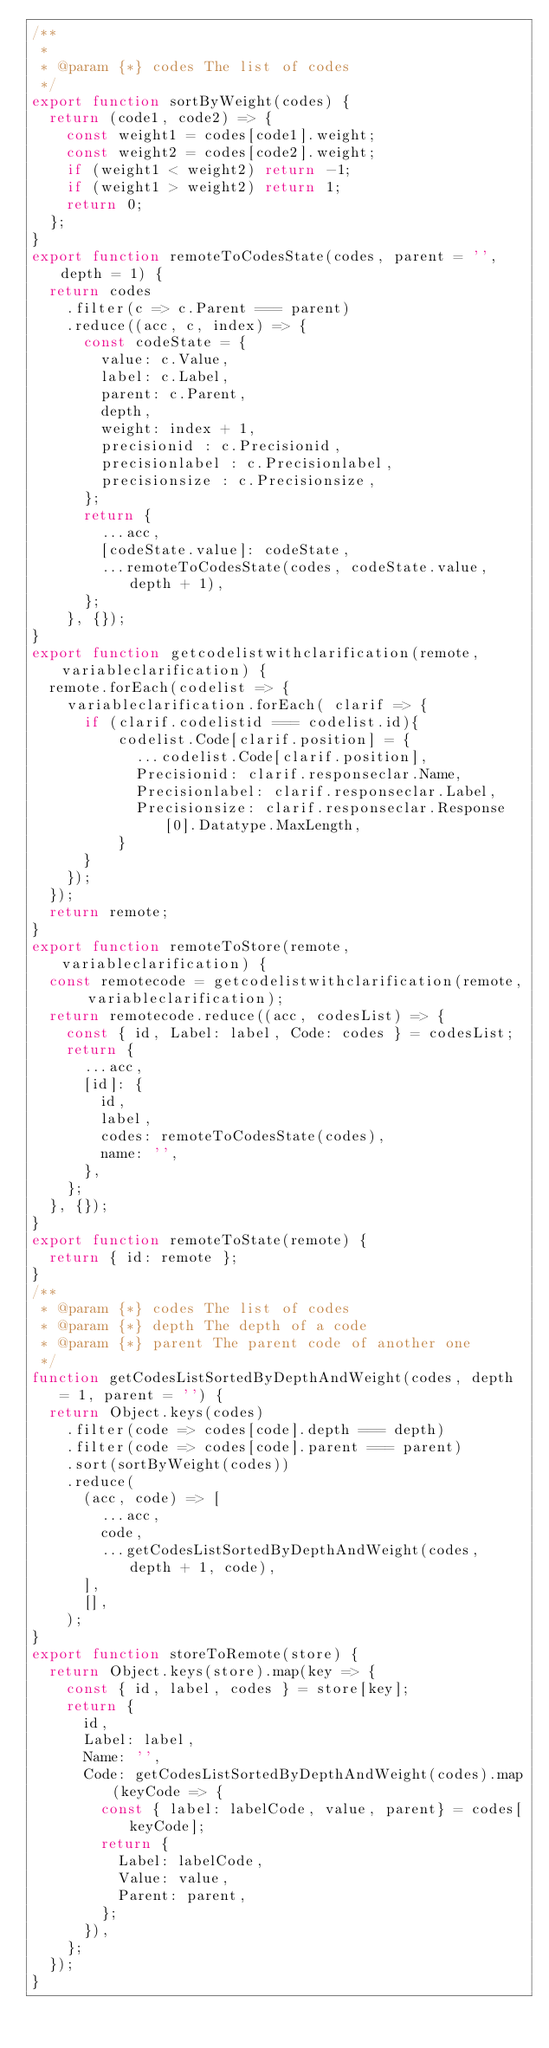Convert code to text. <code><loc_0><loc_0><loc_500><loc_500><_JavaScript_>/**
 *
 * @param {*} codes The list of codes
 */
export function sortByWeight(codes) {
  return (code1, code2) => {
    const weight1 = codes[code1].weight;
    const weight2 = codes[code2].weight;
    if (weight1 < weight2) return -1;
    if (weight1 > weight2) return 1;
    return 0;
  };
}
export function remoteToCodesState(codes, parent = '', depth = 1) {
  return codes
    .filter(c => c.Parent === parent)
    .reduce((acc, c, index) => {
      const codeState = {
        value: c.Value,
        label: c.Label,
        parent: c.Parent,
        depth,
        weight: index + 1,
        precisionid : c.Precisionid,
        precisionlabel : c.Precisionlabel,
        precisionsize : c.Precisionsize,
      };
      return {
        ...acc,
        [codeState.value]: codeState,
        ...remoteToCodesState(codes, codeState.value, depth + 1),
      };
    }, {});
}
export function getcodelistwithclarification(remote, variableclarification) {
  remote.forEach(codelist => {
    variableclarification.forEach( clarif => {
      if (clarif.codelistid === codelist.id){
          codelist.Code[clarif.position] = {
            ...codelist.Code[clarif.position], 
            Precisionid: clarif.responseclar.Name, 
            Precisionlabel: clarif.responseclar.Label,
            Precisionsize: clarif.responseclar.Response[0].Datatype.MaxLength,
          }
      }
    });
  });
  return remote;
}
export function remoteToStore(remote, variableclarification) {
  const remotecode = getcodelistwithclarification(remote, variableclarification);
  return remotecode.reduce((acc, codesList) => {
    const { id, Label: label, Code: codes } = codesList;
    return {
      ...acc,
      [id]: {
        id,
        label,
        codes: remoteToCodesState(codes),
        name: '',
      },
    };
  }, {});
}
export function remoteToState(remote) {
  return { id: remote };
}
/**
 * @param {*} codes The list of codes
 * @param {*} depth The depth of a code
 * @param {*} parent The parent code of another one
 */
function getCodesListSortedByDepthAndWeight(codes, depth = 1, parent = '') {
  return Object.keys(codes)
    .filter(code => codes[code].depth === depth)
    .filter(code => codes[code].parent === parent)
    .sort(sortByWeight(codes))
    .reduce(
      (acc, code) => [
        ...acc,
        code,
        ...getCodesListSortedByDepthAndWeight(codes, depth + 1, code),
      ],
      [],
    );
}
export function storeToRemote(store) {
  return Object.keys(store).map(key => {
    const { id, label, codes } = store[key];
    return {
      id,
      Label: label,
      Name: '',
      Code: getCodesListSortedByDepthAndWeight(codes).map(keyCode => {
        const { label: labelCode, value, parent} = codes[keyCode];
        return {
          Label: labelCode,
          Value: value,
          Parent: parent,
        };
      }),
    };
  });
}
</code> 